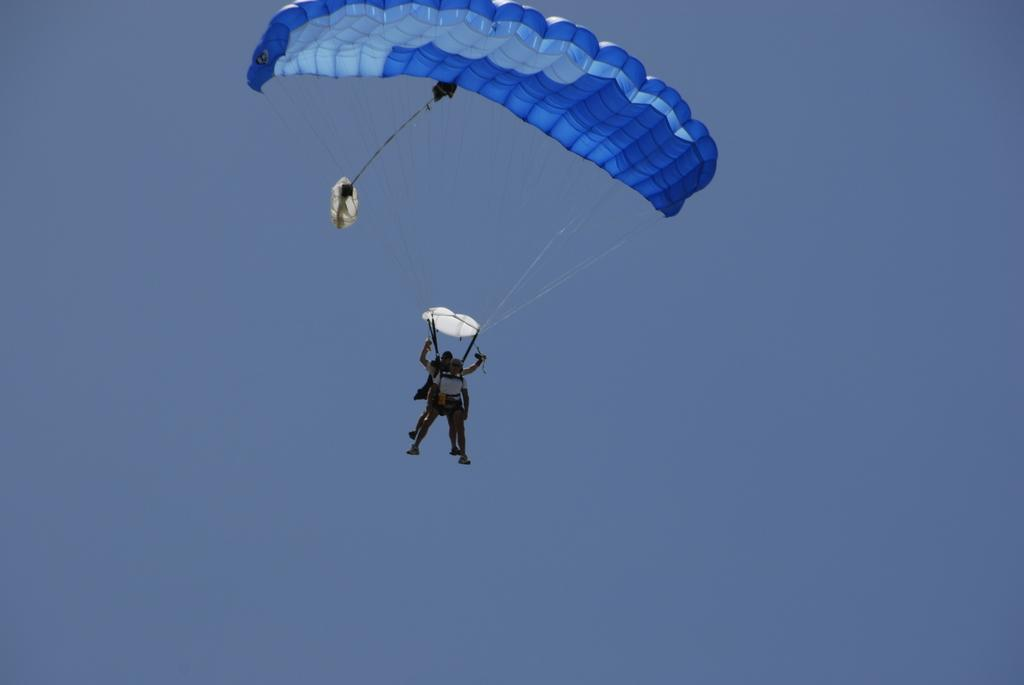How many people are in the image? There are two people in the image. What are the people doing in the image? The people are flying with parachutes. What can be seen in the background of the image? The sky is visible in the background of the image. What type of offer can be seen in the image? There is no offer present in the image; it features two people flying with parachutes against a sky background. 